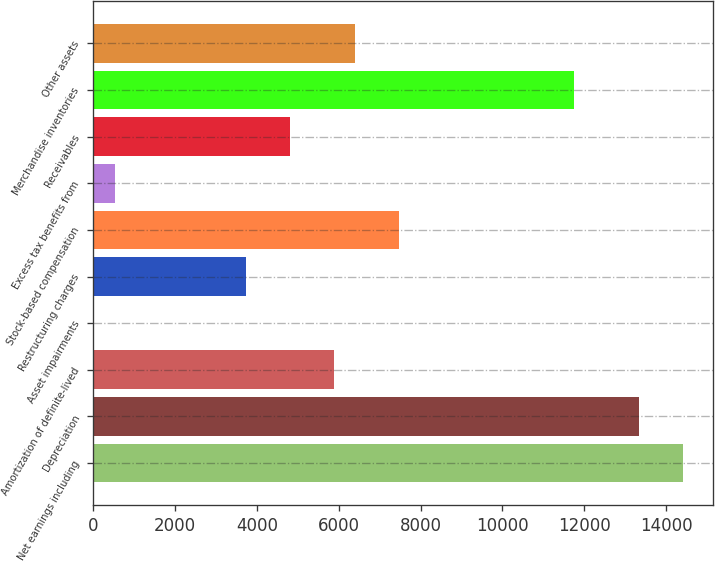Convert chart. <chart><loc_0><loc_0><loc_500><loc_500><bar_chart><fcel>Net earnings including<fcel>Depreciation<fcel>Amortization of definite-lived<fcel>Asset impairments<fcel>Restructuring charges<fcel>Stock-based compensation<fcel>Excess tax benefits from<fcel>Receivables<fcel>Merchandise inventories<fcel>Other assets<nl><fcel>14416.6<fcel>13349<fcel>5875.8<fcel>4<fcel>3740.6<fcel>7477.2<fcel>537.8<fcel>4808.2<fcel>11747.6<fcel>6409.6<nl></chart> 